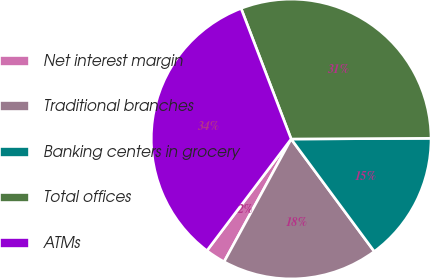Convert chart to OTSL. <chart><loc_0><loc_0><loc_500><loc_500><pie_chart><fcel>Net interest margin<fcel>Traditional branches<fcel>Banking centers in grocery<fcel>Total offices<fcel>ATMs<nl><fcel>2.33%<fcel>18.09%<fcel>14.95%<fcel>30.75%<fcel>33.89%<nl></chart> 